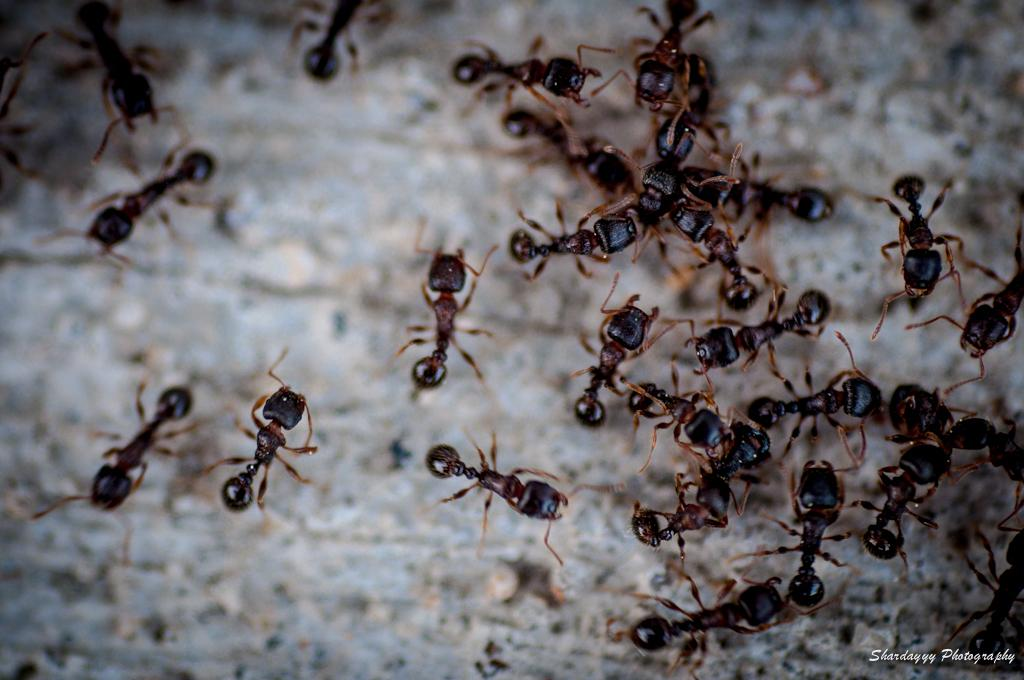What type of creatures are present in the image? There are ants in the image. Where are the ants located? The ants are on the ground. What type of bat is flying in the image? There is no bat present in the image; it features ants on the ground. What kind of apparatus is being used by the ants in the image? There is no apparatus present in the image; it only features ants on the ground. 